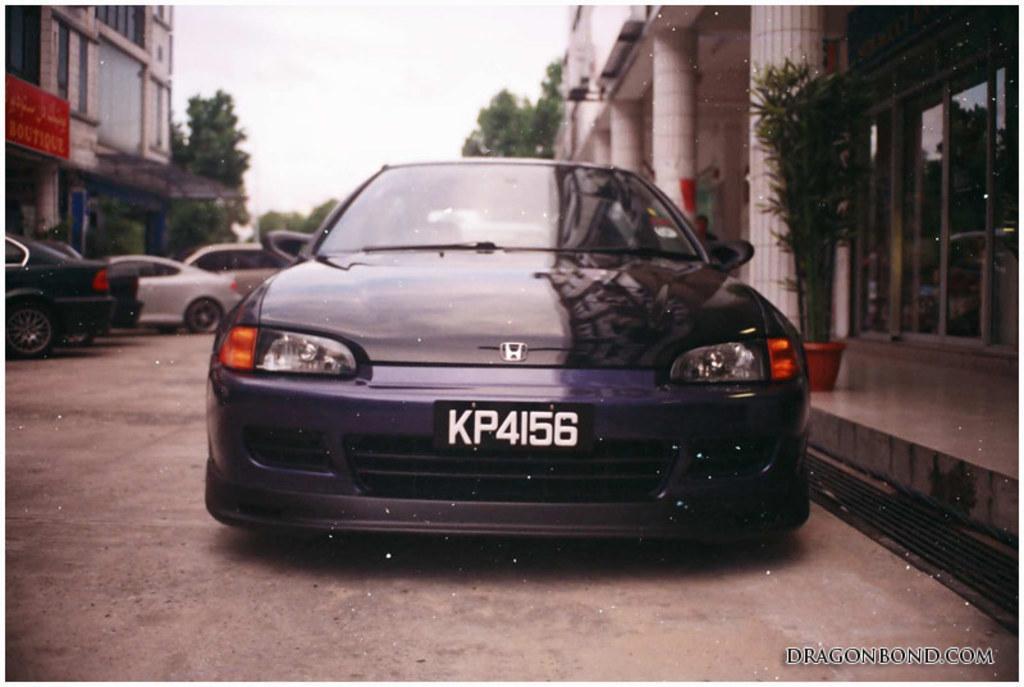Please provide a concise description of this image. In the image there are few cars on the road with buildings on either side of it with trees in front of them and above its sky. 